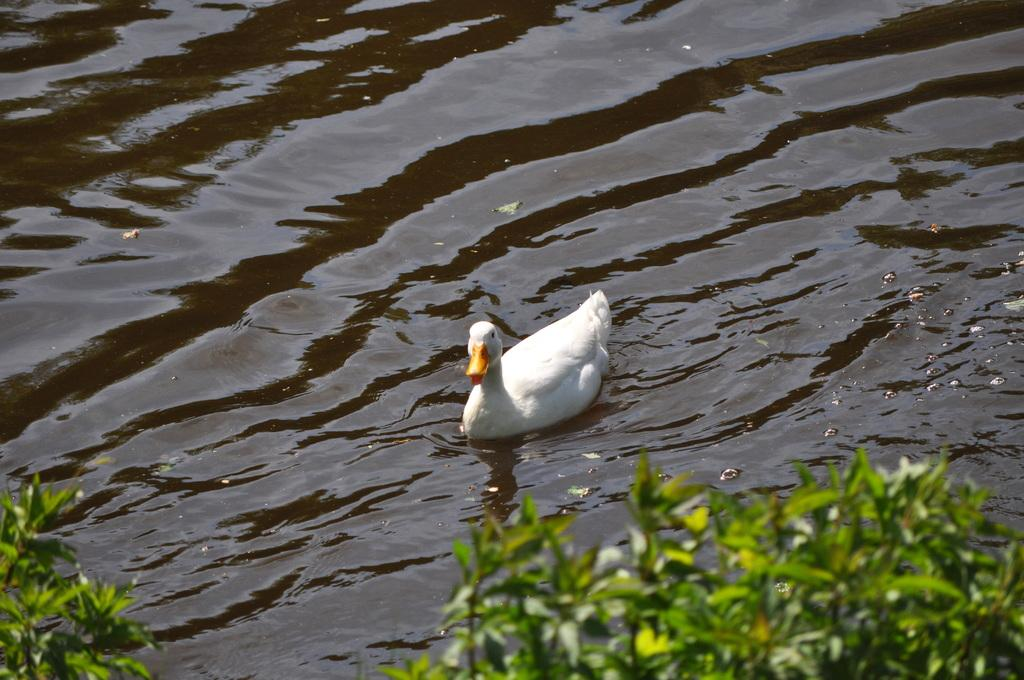What is the main subject in the center of the image? There is a duck in the center of the image. Where is the duck located? The duck is on the water. What can be seen in the background of the image? There are plants visible in the background of the image. How many rabbits can be seen playing with the boundary in the image? There are no rabbits or boundaries present in the image; it features a duck on the water with plants in the background. 